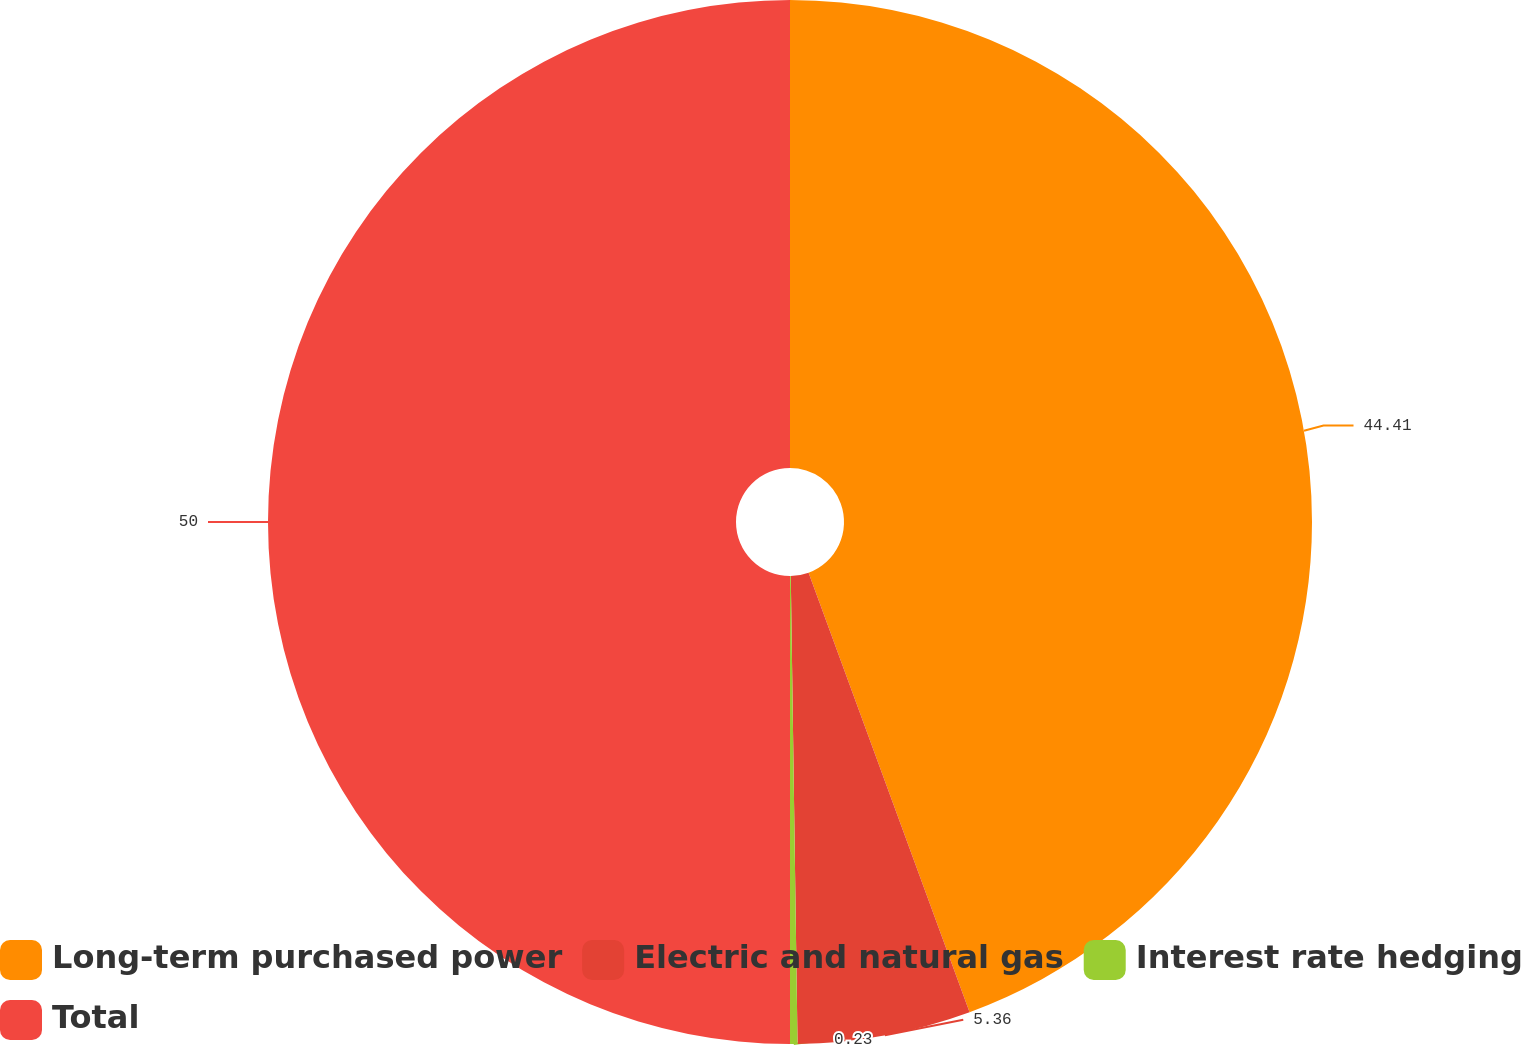Convert chart to OTSL. <chart><loc_0><loc_0><loc_500><loc_500><pie_chart><fcel>Long-term purchased power<fcel>Electric and natural gas<fcel>Interest rate hedging<fcel>Total<nl><fcel>44.41%<fcel>5.36%<fcel>0.23%<fcel>50.0%<nl></chart> 